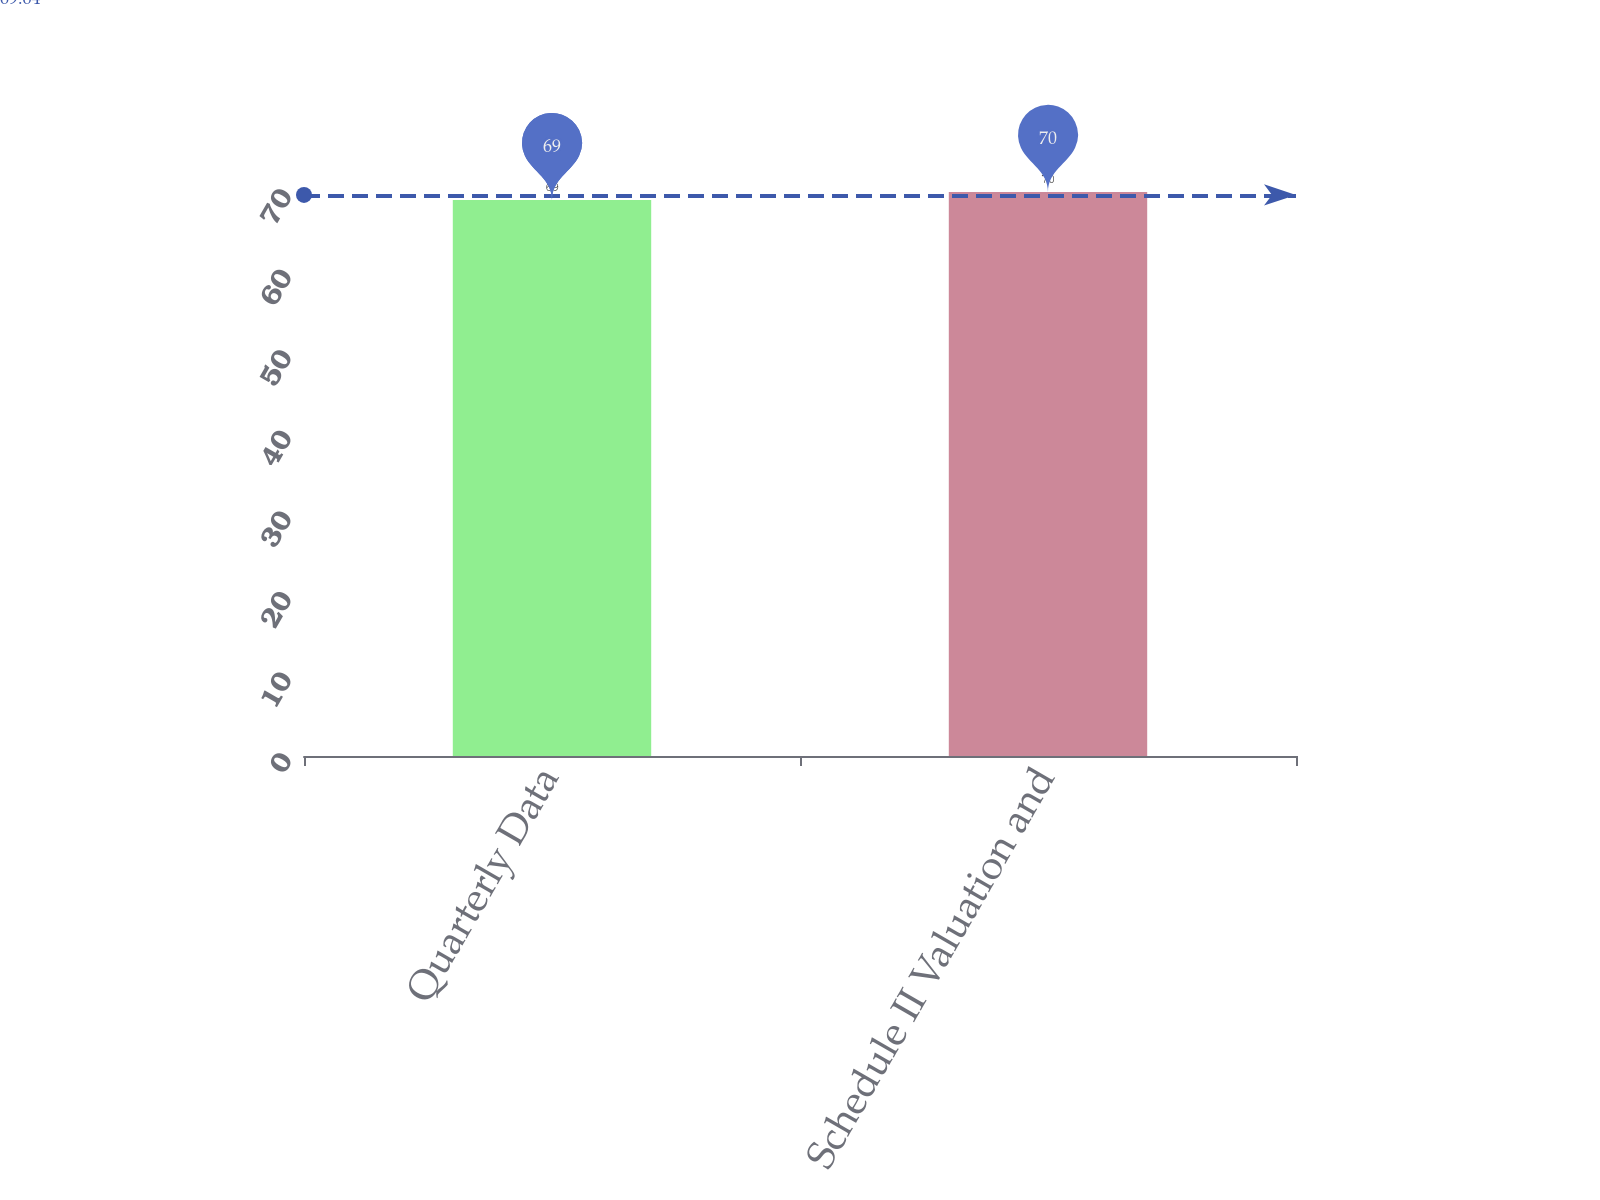Convert chart to OTSL. <chart><loc_0><loc_0><loc_500><loc_500><bar_chart><fcel>Quarterly Data<fcel>Schedule II Valuation and<nl><fcel>69<fcel>70<nl></chart> 